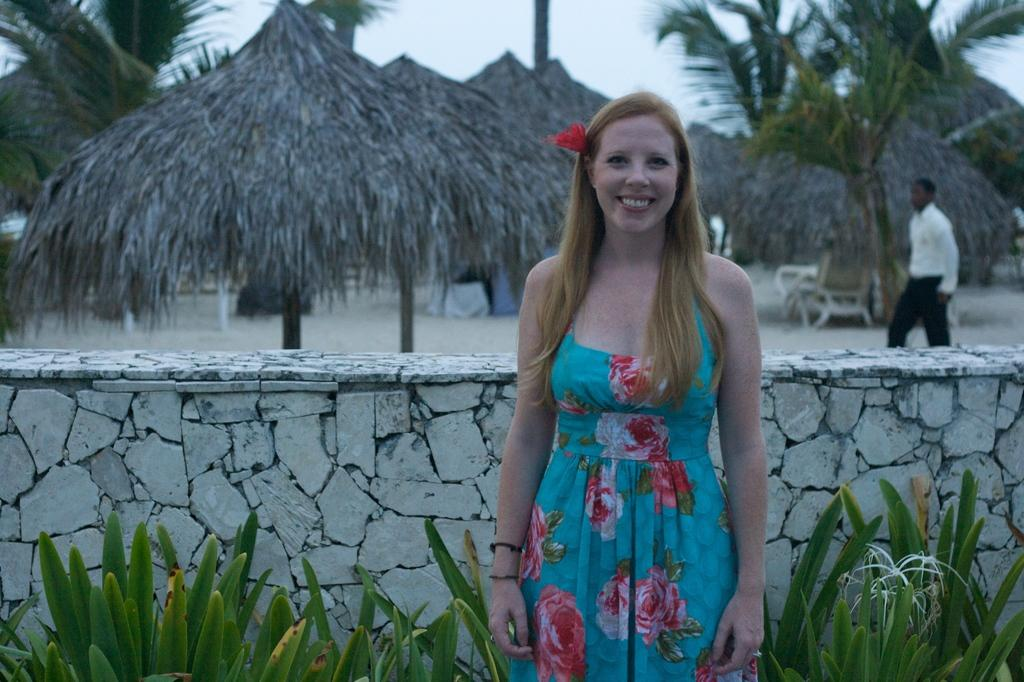What is the main subject of the image? There is a woman standing in the image. What can be seen in the image besides the woman? There are plants, a wall, and objects in the background of the image. What is visible in the background of the image? In the background, there is a person visible, trees, wooden umbrellas, and the sky. What type of picture is the woman holding in the image? There is no picture visible in the woman's hands in the image. How does the woman cause death in the image? The image does not depict any actions or events related to death. 